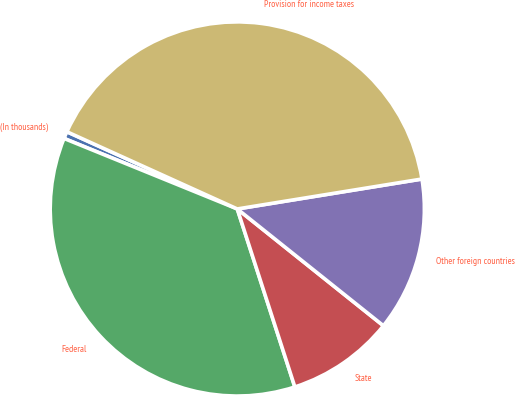Convert chart. <chart><loc_0><loc_0><loc_500><loc_500><pie_chart><fcel>(In thousands)<fcel>Federal<fcel>State<fcel>Other foreign countries<fcel>Provision for income taxes<nl><fcel>0.62%<fcel>36.13%<fcel>9.29%<fcel>13.29%<fcel>40.67%<nl></chart> 